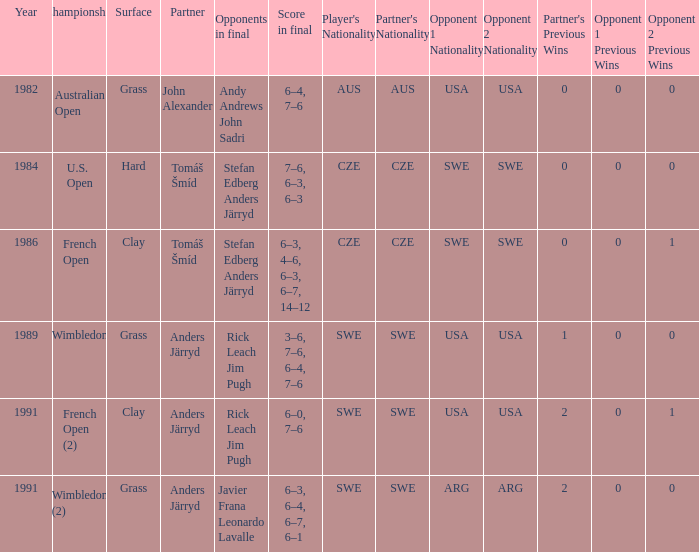What was the final score in 1986? 6–3, 4–6, 6–3, 6–7, 14–12. 